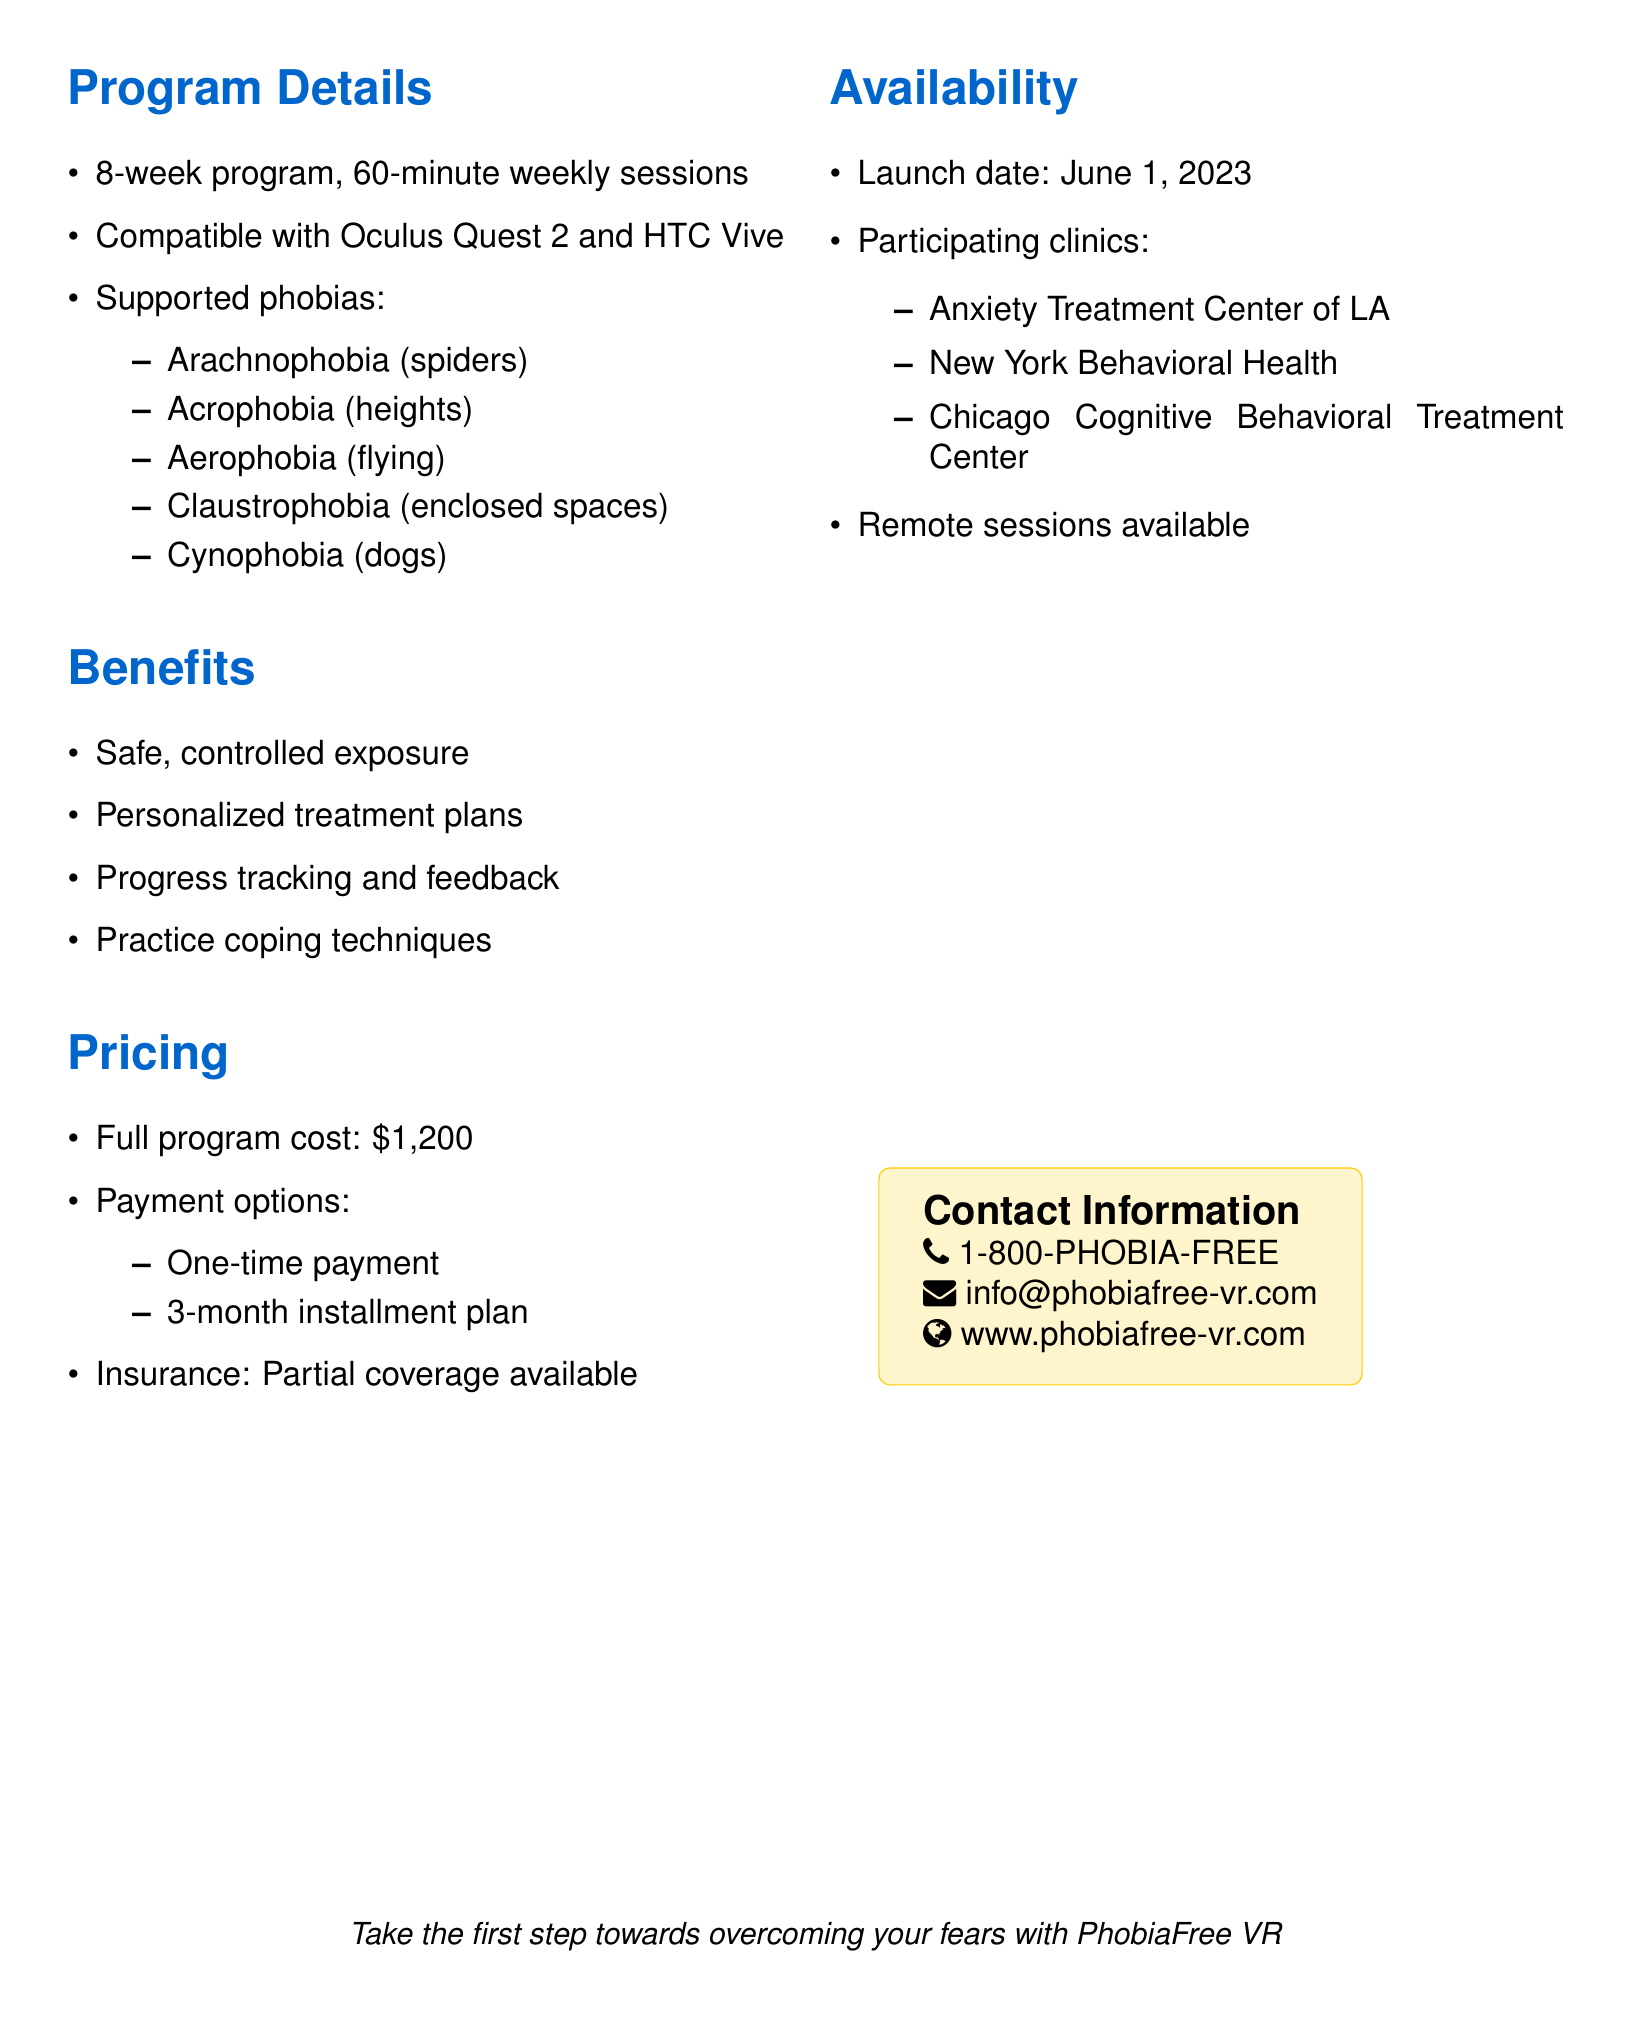What is the name of the program? The name of the program is mentioned as "PhobiaFree VR" in the introduction section.
Answer: PhobiaFree VR Who developed the program? The email states that the program is developed by "MindWell Technologies."
Answer: MindWell Technologies How long is the therapy program? The duration of the program is specified as "8-week program" in the details section.
Answer: 8-week program What is the cost of the full program? The pricing section lists the full program cost as "$1,200."
Answer: $1,200 Which phobia is related to the fear of heights? The phobia related to heights is "Acrophobia," listed under supported phobias.
Answer: Acrophobia When will the program be available? The launch date is specified in the availability section as "June 1, 2023."
Answer: June 1, 2023 What payment options are available for the program? The available payment options are mentioned as "One-time payment" and "3-month installment plan."
Answer: One-time payment, 3-month installment plan What type of sessions are available at home? The availability section indicates that "Remote sessions" are available with therapist guidance.
Answer: Remote sessions Which clinic is located in Chicago? One of the participating clinics listed in the document is the "Chicago Cognitive Behavioral Treatment Center."
Answer: Chicago Cognitive Behavioral Treatment Center 